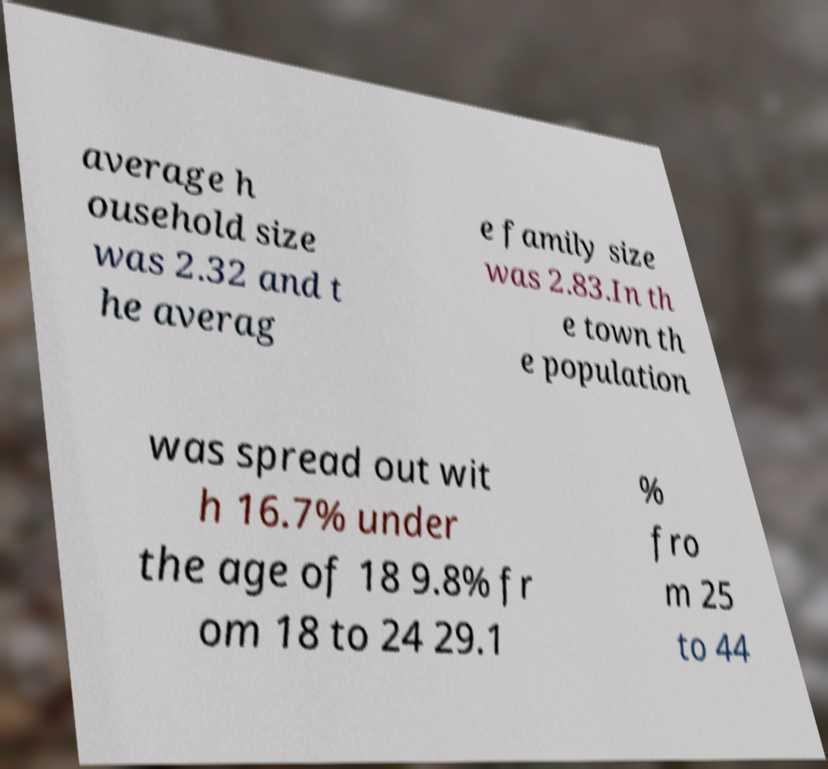Can you accurately transcribe the text from the provided image for me? average h ousehold size was 2.32 and t he averag e family size was 2.83.In th e town th e population was spread out wit h 16.7% under the age of 18 9.8% fr om 18 to 24 29.1 % fro m 25 to 44 